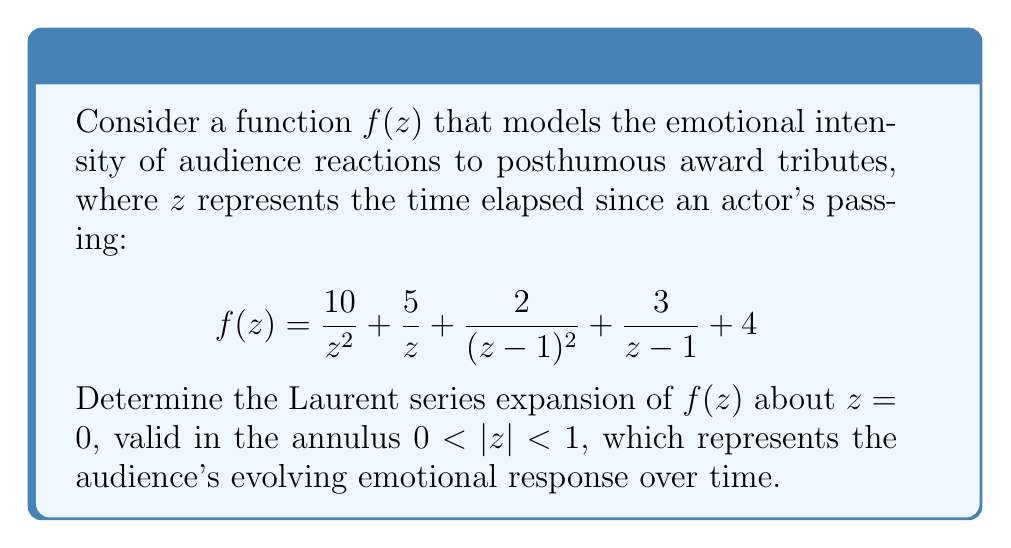Provide a solution to this math problem. To find the Laurent series expansion of $f(z)$ about $z = 0$, we need to express each term in the function as a power series centered at $z = 0$.

1) For the terms $\frac{10}{z^2}$ and $\frac{5}{z}$, these are already in the form of negative powers of $z$ and don't need expansion.

2) For the constant term 4, this remains as is in the expansion.

3) For the terms $\frac{2}{(z-1)^2}$ and $\frac{3}{z-1}$, we need to use the geometric series expansion:

   $\frac{1}{1-z} = 1 + z + z^2 + z^3 + \cdots$ for $|z| < 1$

   Differentiating both sides:
   $\frac{1}{(1-z)^2} = 1 + 2z + 3z^2 + 4z^3 + \cdots$ for $|z| < 1$

   Therefore:
   $\frac{2}{(z-1)^2} = 2(1 + 2z + 3z^2 + 4z^3 + \cdots)$
   $= 2 + 4z + 6z^2 + 8z^3 + \cdots$

   $\frac{3}{z-1} = -3(\frac{1}{1-z}) = -3(1 + z + z^2 + z^3 + \cdots)$
   $= -3 - 3z - 3z^2 - 3z^3 - \cdots$

4) Combining all terms:

   $f(z) = \frac{10}{z^2} + \frac{5}{z} + (2 + 4z + 6z^2 + 8z^3 + \cdots) + (-3 - 3z - 3z^2 - 3z^3 - \cdots) + 4$

5) Grouping like terms:

   $f(z) = \frac{10}{z^2} + \frac{5}{z} + 3 + z + 3z^2 + 5z^3 + \cdots$

This is the Laurent series expansion of $f(z)$ about $z = 0$, valid for $0 < |z| < 1$.
Answer: $f(z) = \frac{10}{z^2} + \frac{5}{z} + 3 + z + 3z^2 + 5z^3 + \cdots$, for $0 < |z| < 1$ 